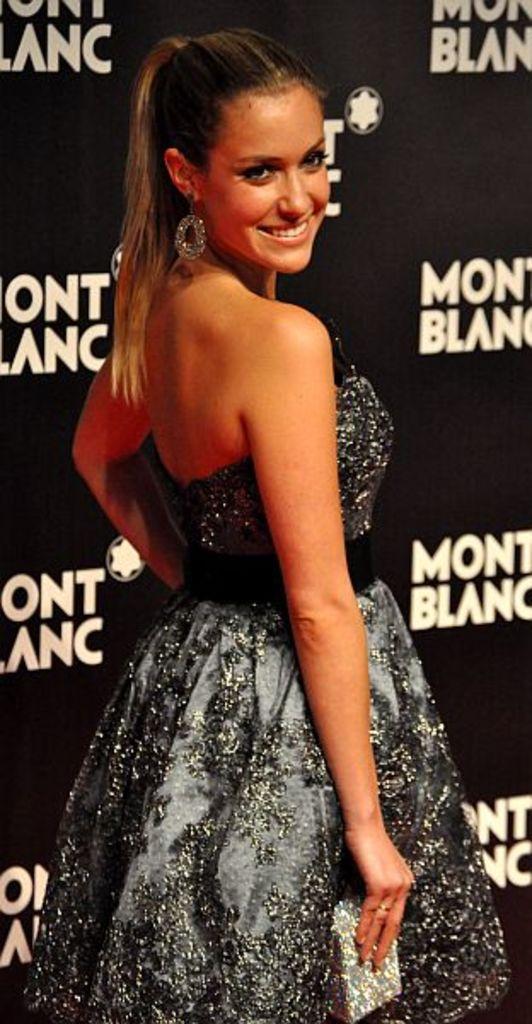Can you describe this image briefly? In this picture we can see a woman holding an object in her hand and smiling. We can see some text and a few things on the black object. 